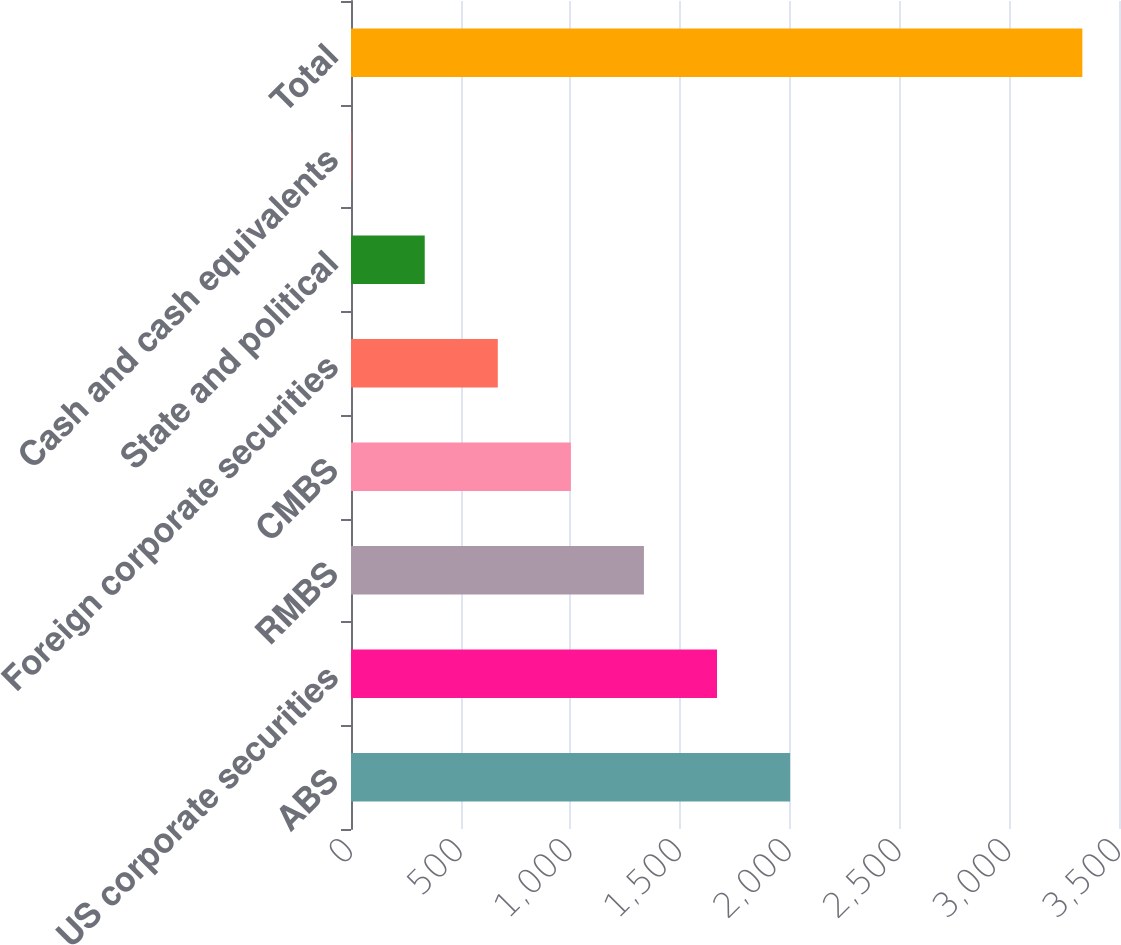Convert chart. <chart><loc_0><loc_0><loc_500><loc_500><bar_chart><fcel>ABS<fcel>US corporate securities<fcel>RMBS<fcel>CMBS<fcel>Foreign corporate securities<fcel>State and political<fcel>Cash and cash equivalents<fcel>Total<nl><fcel>2001<fcel>1668<fcel>1335<fcel>1002<fcel>669<fcel>336<fcel>3<fcel>3333<nl></chart> 